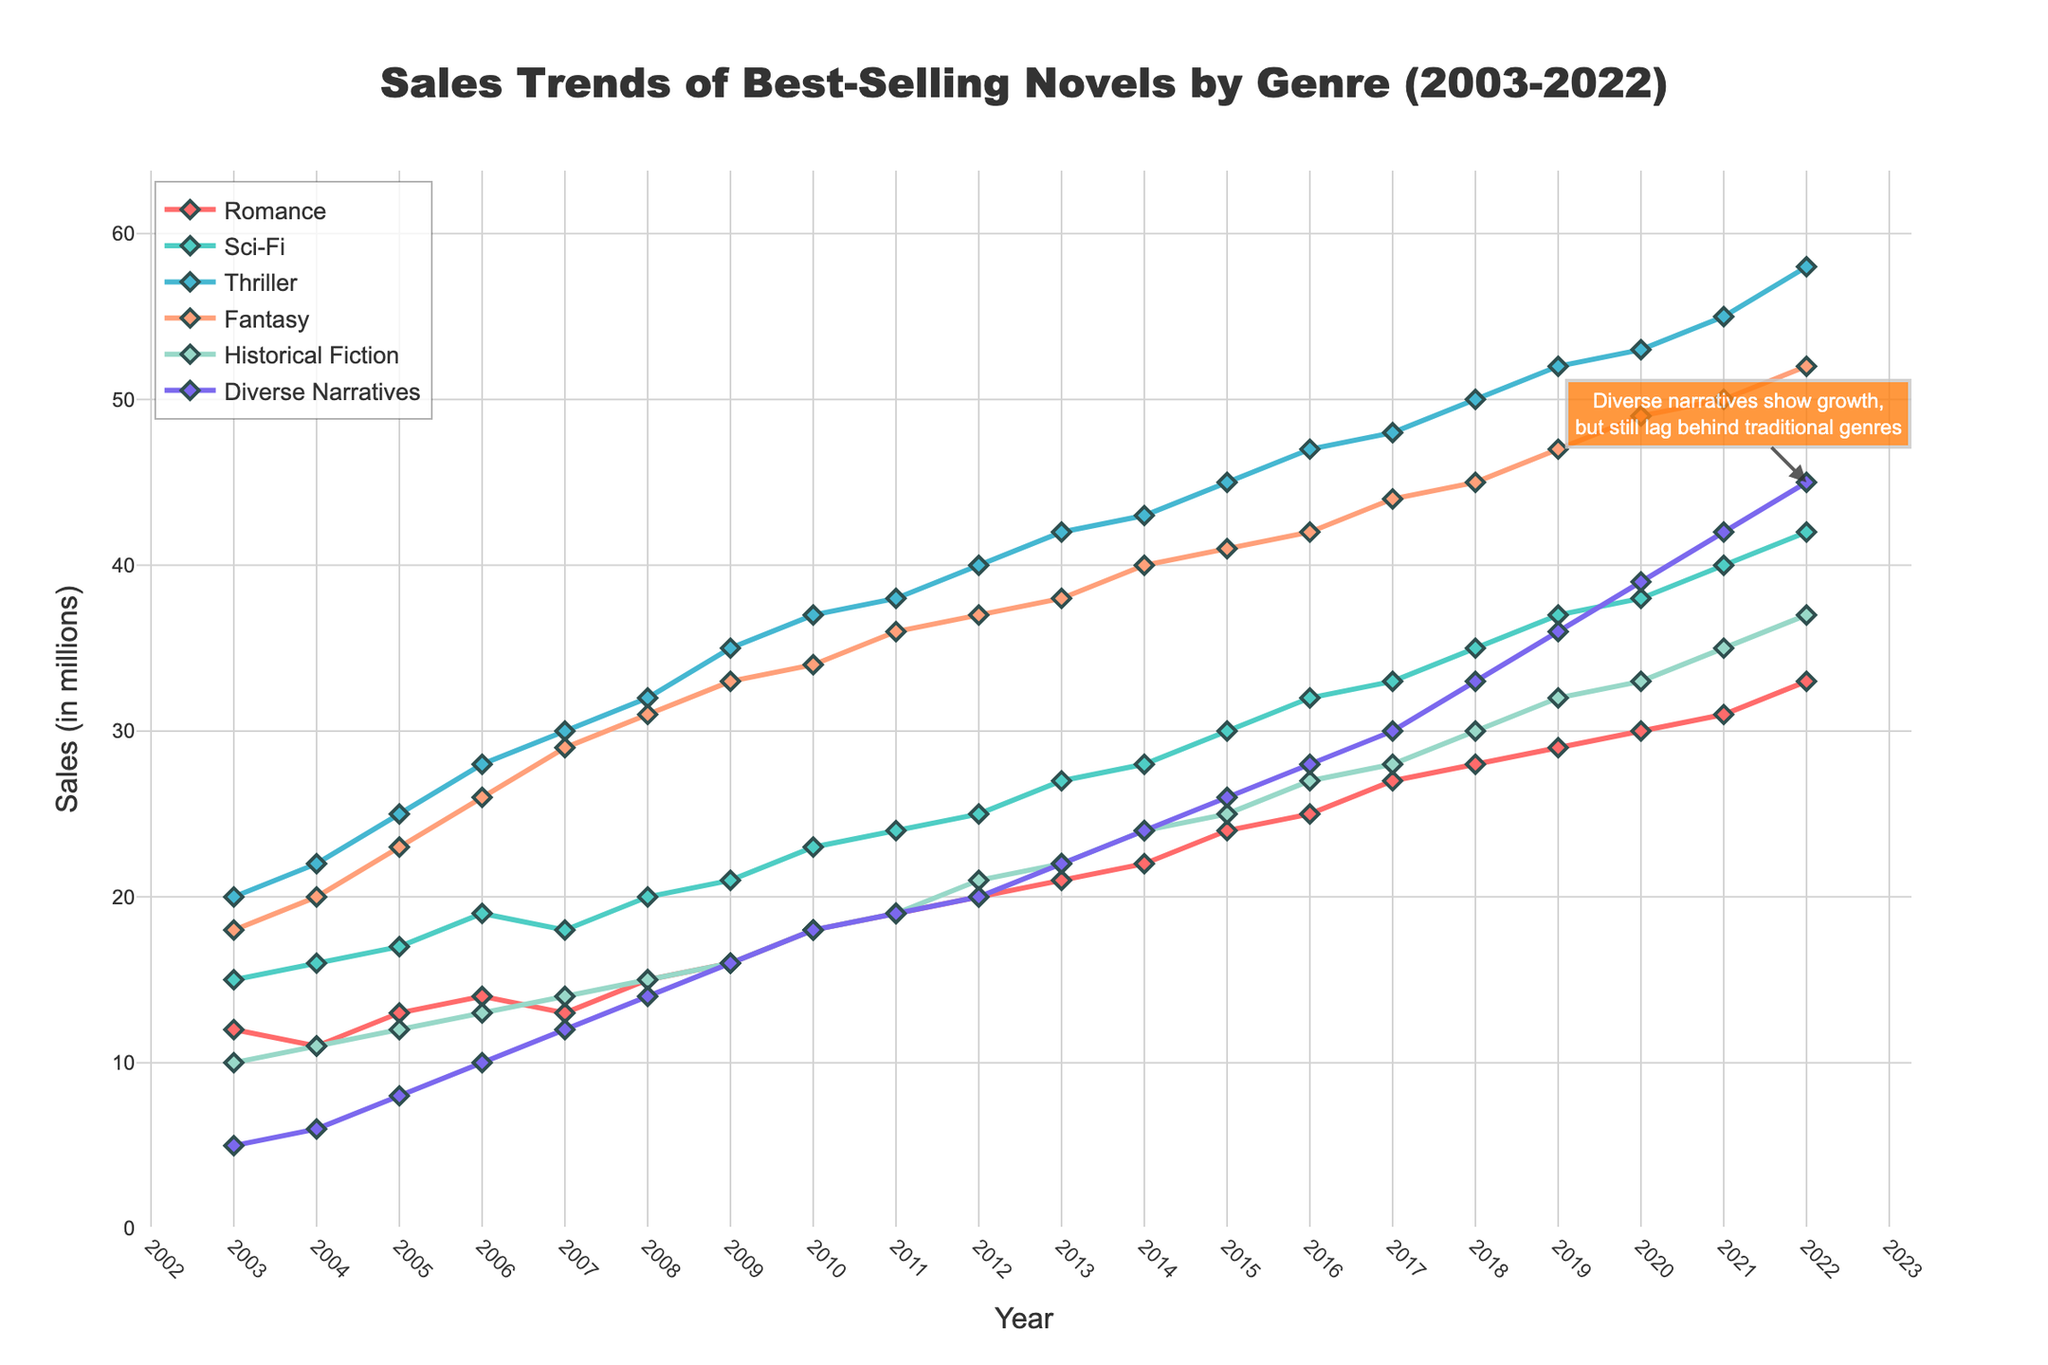What's the title of the plot? The title is positioned prominently at the top center of the plot and reads "Sales Trends of Best-Selling Novels by Genre (2003-2022)".
Answer: Sales Trends of Best-Selling Novels by Genre (2003-2022) Which genre had the highest sales in 2022? By looking at the plot annotations for the year 2022, the genre with the highest point is "Thriller" at 58 million sales.
Answer: Thriller What is the general trend for Diverse Narratives over the last 20 years? The plot shows a line graph for Diverse Narratives that consistently rises from 5 million in 2003 to 45 million in 2022, indicating a steady upward trend.
Answer: Upward trend How do the sales trends of Romance and Sci-Fi compare in 2022? Comparing the end points for 2022, Romance has 33 million sales and Sci-Fi has 42 million sales. Sci-Fi leads by a margin of 9 million.
Answer: Sci-Fi leads by 9 million Between which years did Fantasy see the most significant increase in sales? Observing the plot, the largest year-to-year increase for Fantasy occurs between 2006 and 2007 where it rose from 26 million to 29 million.
Answer: Between 2006 and 2007 What is the average sales growth rate per year for Historical Fiction? The sales for Historical Fiction in 2022 is 37 million and in 2003 it was 10 million. Over 19 years, the average growth rate per year is (37-10)/19.
Answer: 1.42 million per year In what year did Diverse Narratives surpass 20 million in sales? Referring to the Diverse Narratives line, it crosses the 20 million mark between 2011 and 2012.
Answer: 2012 Compare the sales of Romance in 2010 and Fantasy in the same year. Which is higher? Checking 2010 on the plot, Romance has 18 million while Fantasy stands at 34 million. Fantasy is higher.
Answer: Fantasy is higher How does the trend of Diverse Narratives' sales compare to the other genres? While Diverse Narratives is on a steady upward trend, it consistently lags behind the other established genres like Thriller, Fantasy, and Sci-Fi which have higher sales throughout the 20 years.
Answer: Lags behind others What's the difference in sales between Thrillers and Diverse Narratives in 2020? Reviewing the 2020 data points, Thrillers have 53 million in sales, and Diverse Narratives have 39 million. The difference is 53 - 39.
Answer: 14 million 